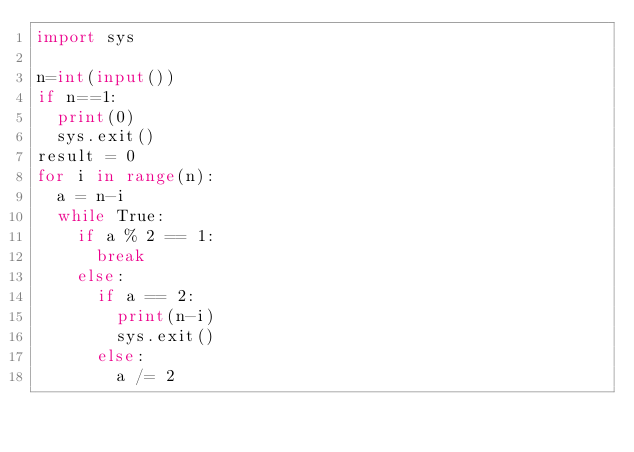<code> <loc_0><loc_0><loc_500><loc_500><_Python_>import sys

n=int(input())
if n==1:
  print(0)
  sys.exit()
result = 0
for i in range(n):
  a = n-i
  while True:
    if a % 2 == 1:
      break
    else:
      if a == 2:
        print(n-i)
        sys.exit()
      else:
        a /= 2
</code> 